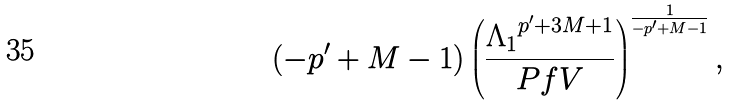Convert formula to latex. <formula><loc_0><loc_0><loc_500><loc_500>( - p ^ { \prime } + M - 1 ) \left ( \frac { { \Lambda _ { 1 } } ^ { p ^ { \prime } + 3 M + 1 } } { P f V } \right ) ^ { \frac { 1 } { - p ^ { \prime } + M - 1 } } ,</formula> 